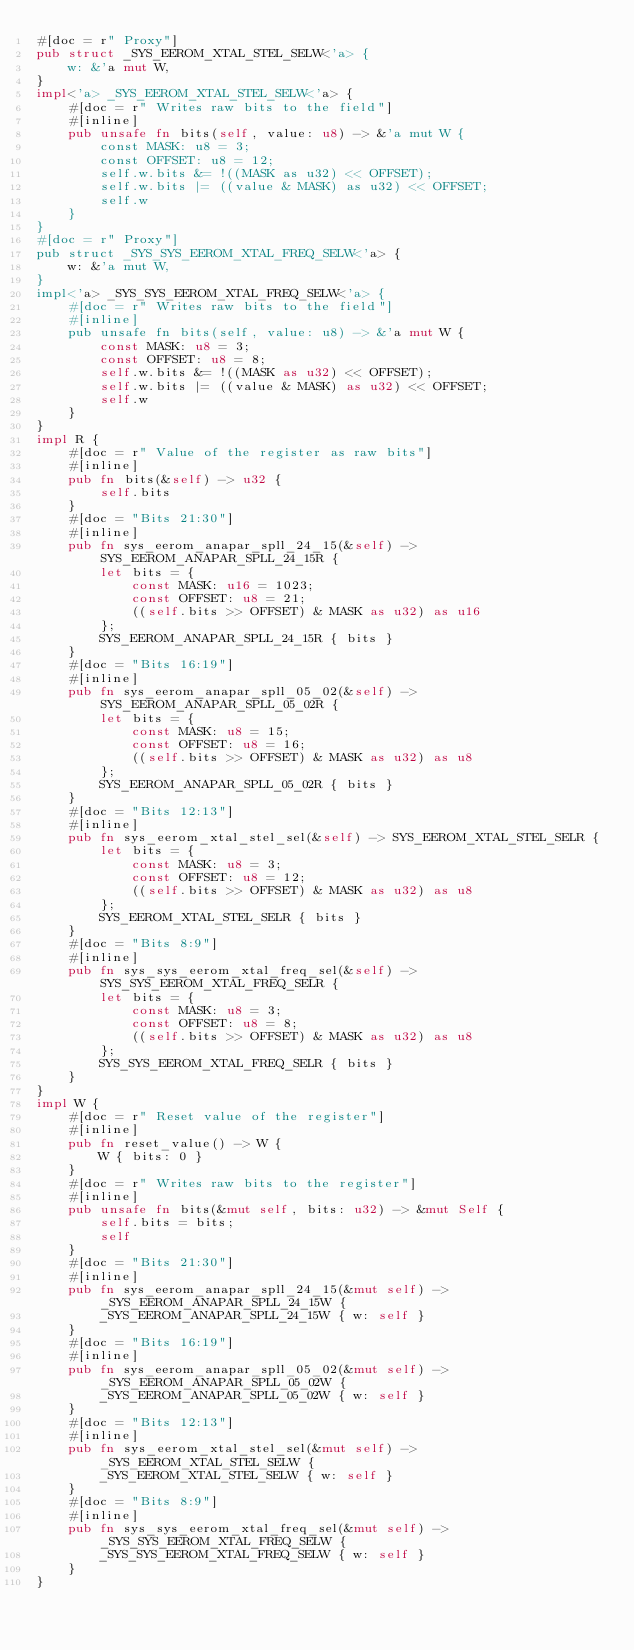Convert code to text. <code><loc_0><loc_0><loc_500><loc_500><_Rust_>#[doc = r" Proxy"]
pub struct _SYS_EEROM_XTAL_STEL_SELW<'a> {
    w: &'a mut W,
}
impl<'a> _SYS_EEROM_XTAL_STEL_SELW<'a> {
    #[doc = r" Writes raw bits to the field"]
    #[inline]
    pub unsafe fn bits(self, value: u8) -> &'a mut W {
        const MASK: u8 = 3;
        const OFFSET: u8 = 12;
        self.w.bits &= !((MASK as u32) << OFFSET);
        self.w.bits |= ((value & MASK) as u32) << OFFSET;
        self.w
    }
}
#[doc = r" Proxy"]
pub struct _SYS_SYS_EEROM_XTAL_FREQ_SELW<'a> {
    w: &'a mut W,
}
impl<'a> _SYS_SYS_EEROM_XTAL_FREQ_SELW<'a> {
    #[doc = r" Writes raw bits to the field"]
    #[inline]
    pub unsafe fn bits(self, value: u8) -> &'a mut W {
        const MASK: u8 = 3;
        const OFFSET: u8 = 8;
        self.w.bits &= !((MASK as u32) << OFFSET);
        self.w.bits |= ((value & MASK) as u32) << OFFSET;
        self.w
    }
}
impl R {
    #[doc = r" Value of the register as raw bits"]
    #[inline]
    pub fn bits(&self) -> u32 {
        self.bits
    }
    #[doc = "Bits 21:30"]
    #[inline]
    pub fn sys_eerom_anapar_spll_24_15(&self) -> SYS_EEROM_ANAPAR_SPLL_24_15R {
        let bits = {
            const MASK: u16 = 1023;
            const OFFSET: u8 = 21;
            ((self.bits >> OFFSET) & MASK as u32) as u16
        };
        SYS_EEROM_ANAPAR_SPLL_24_15R { bits }
    }
    #[doc = "Bits 16:19"]
    #[inline]
    pub fn sys_eerom_anapar_spll_05_02(&self) -> SYS_EEROM_ANAPAR_SPLL_05_02R {
        let bits = {
            const MASK: u8 = 15;
            const OFFSET: u8 = 16;
            ((self.bits >> OFFSET) & MASK as u32) as u8
        };
        SYS_EEROM_ANAPAR_SPLL_05_02R { bits }
    }
    #[doc = "Bits 12:13"]
    #[inline]
    pub fn sys_eerom_xtal_stel_sel(&self) -> SYS_EEROM_XTAL_STEL_SELR {
        let bits = {
            const MASK: u8 = 3;
            const OFFSET: u8 = 12;
            ((self.bits >> OFFSET) & MASK as u32) as u8
        };
        SYS_EEROM_XTAL_STEL_SELR { bits }
    }
    #[doc = "Bits 8:9"]
    #[inline]
    pub fn sys_sys_eerom_xtal_freq_sel(&self) -> SYS_SYS_EEROM_XTAL_FREQ_SELR {
        let bits = {
            const MASK: u8 = 3;
            const OFFSET: u8 = 8;
            ((self.bits >> OFFSET) & MASK as u32) as u8
        };
        SYS_SYS_EEROM_XTAL_FREQ_SELR { bits }
    }
}
impl W {
    #[doc = r" Reset value of the register"]
    #[inline]
    pub fn reset_value() -> W {
        W { bits: 0 }
    }
    #[doc = r" Writes raw bits to the register"]
    #[inline]
    pub unsafe fn bits(&mut self, bits: u32) -> &mut Self {
        self.bits = bits;
        self
    }
    #[doc = "Bits 21:30"]
    #[inline]
    pub fn sys_eerom_anapar_spll_24_15(&mut self) -> _SYS_EEROM_ANAPAR_SPLL_24_15W {
        _SYS_EEROM_ANAPAR_SPLL_24_15W { w: self }
    }
    #[doc = "Bits 16:19"]
    #[inline]
    pub fn sys_eerom_anapar_spll_05_02(&mut self) -> _SYS_EEROM_ANAPAR_SPLL_05_02W {
        _SYS_EEROM_ANAPAR_SPLL_05_02W { w: self }
    }
    #[doc = "Bits 12:13"]
    #[inline]
    pub fn sys_eerom_xtal_stel_sel(&mut self) -> _SYS_EEROM_XTAL_STEL_SELW {
        _SYS_EEROM_XTAL_STEL_SELW { w: self }
    }
    #[doc = "Bits 8:9"]
    #[inline]
    pub fn sys_sys_eerom_xtal_freq_sel(&mut self) -> _SYS_SYS_EEROM_XTAL_FREQ_SELW {
        _SYS_SYS_EEROM_XTAL_FREQ_SELW { w: self }
    }
}
</code> 